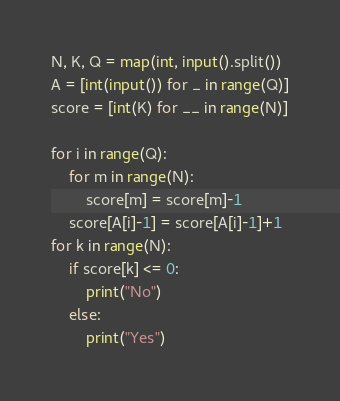<code> <loc_0><loc_0><loc_500><loc_500><_Python_>N, K, Q = map(int, input().split())
A = [int(input()) for _ in range(Q)]
score = [int(K) for __ in range(N)]

for i in range(Q):
    for m in range(N):
        score[m] = score[m]-1
    score[A[i]-1] = score[A[i]-1]+1
for k in range(N):
    if score[k] <= 0:
        print("No")
    else:
        print("Yes")
</code> 